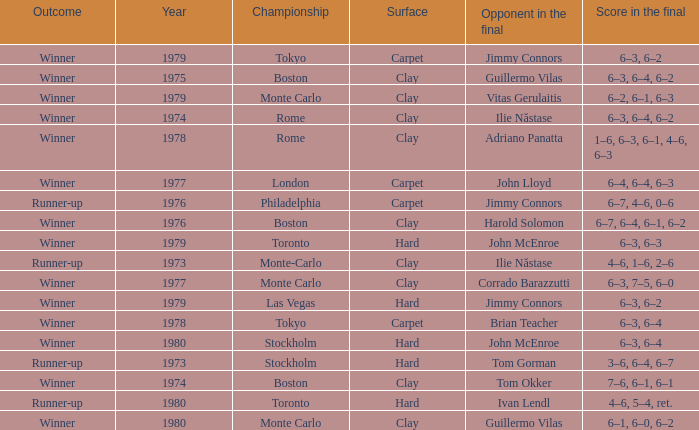Name the total number of opponent in the final for 6–2, 6–1, 6–3 1.0. 